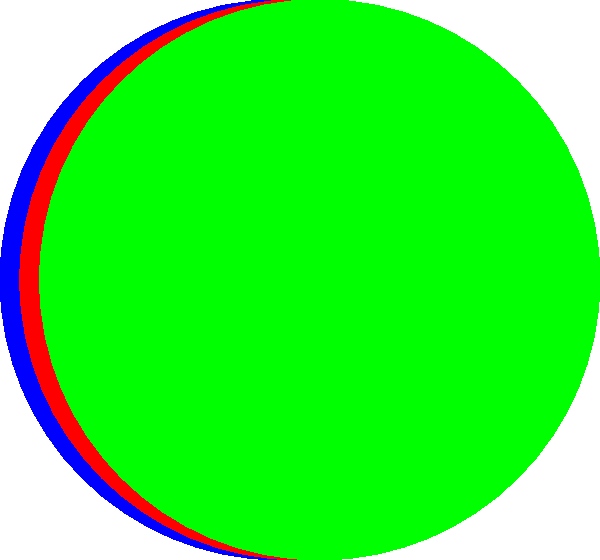Based on the graph showing the estimated time needed to complete homework assignments for different subjects and difficulty levels, how much longer does a hard Science assignment take compared to an easy Science assignment? To find the difference in time between a hard Science assignment and an easy Science assignment, we need to:

1. Identify the time for a hard Science assignment:
   From the graph, we can see that the red bar (medium difficulty) for Science reaches 45 minutes, and the green bar (hard difficulty) extends beyond that to 75 minutes.

2. Identify the time for an easy Science assignment:
   The blue bar (easy difficulty) for Science reaches 30 minutes.

3. Calculate the difference:
   $75 \text{ minutes} - 30 \text{ minutes} = 45 \text{ minutes}$

Therefore, a hard Science assignment takes 45 minutes longer than an easy Science assignment.
Answer: 45 minutes 